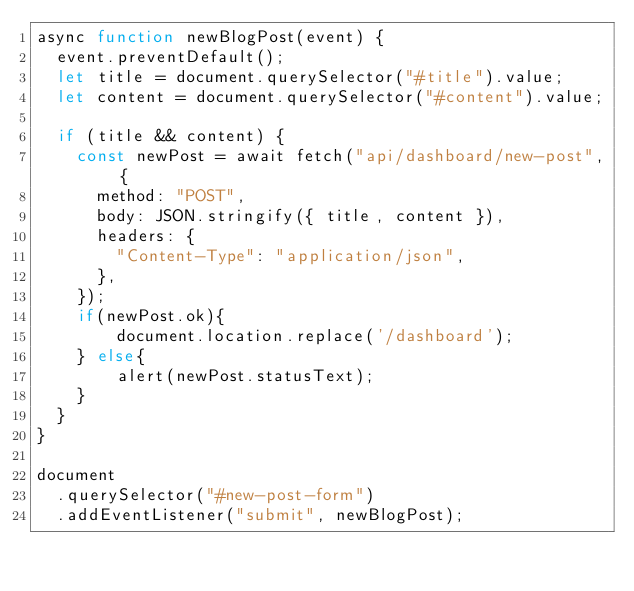Convert code to text. <code><loc_0><loc_0><loc_500><loc_500><_JavaScript_>async function newBlogPost(event) {
  event.preventDefault();
  let title = document.querySelector("#title").value;
  let content = document.querySelector("#content").value;

  if (title && content) {
    const newPost = await fetch("api/dashboard/new-post", {
      method: "POST",
      body: JSON.stringify({ title, content }),
      headers: {
        "Content-Type": "application/json",
      },
    });
    if(newPost.ok){
        document.location.replace('/dashboard');
    } else{
        alert(newPost.statusText);
    }
  }
}

document
  .querySelector("#new-post-form")
  .addEventListener("submit", newBlogPost);
</code> 